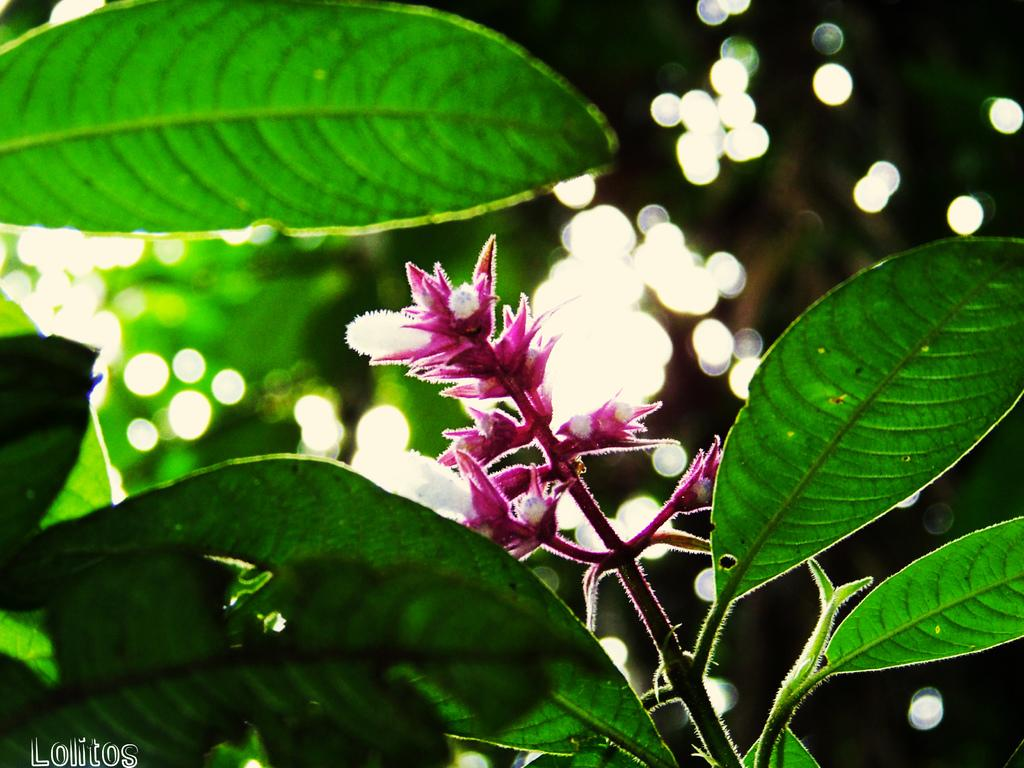What type of plant life is visible in the image? There are flowers in the image. Can you describe the flowers in more detail? The flowers have leaves on the stem in the image. What type of error can be seen in the image? There is no error present in the image; it features flowers with leaves on the stem. What season is depicted in the image? The provided facts do not mention any seasonal details, so it cannot be determined from the image. 